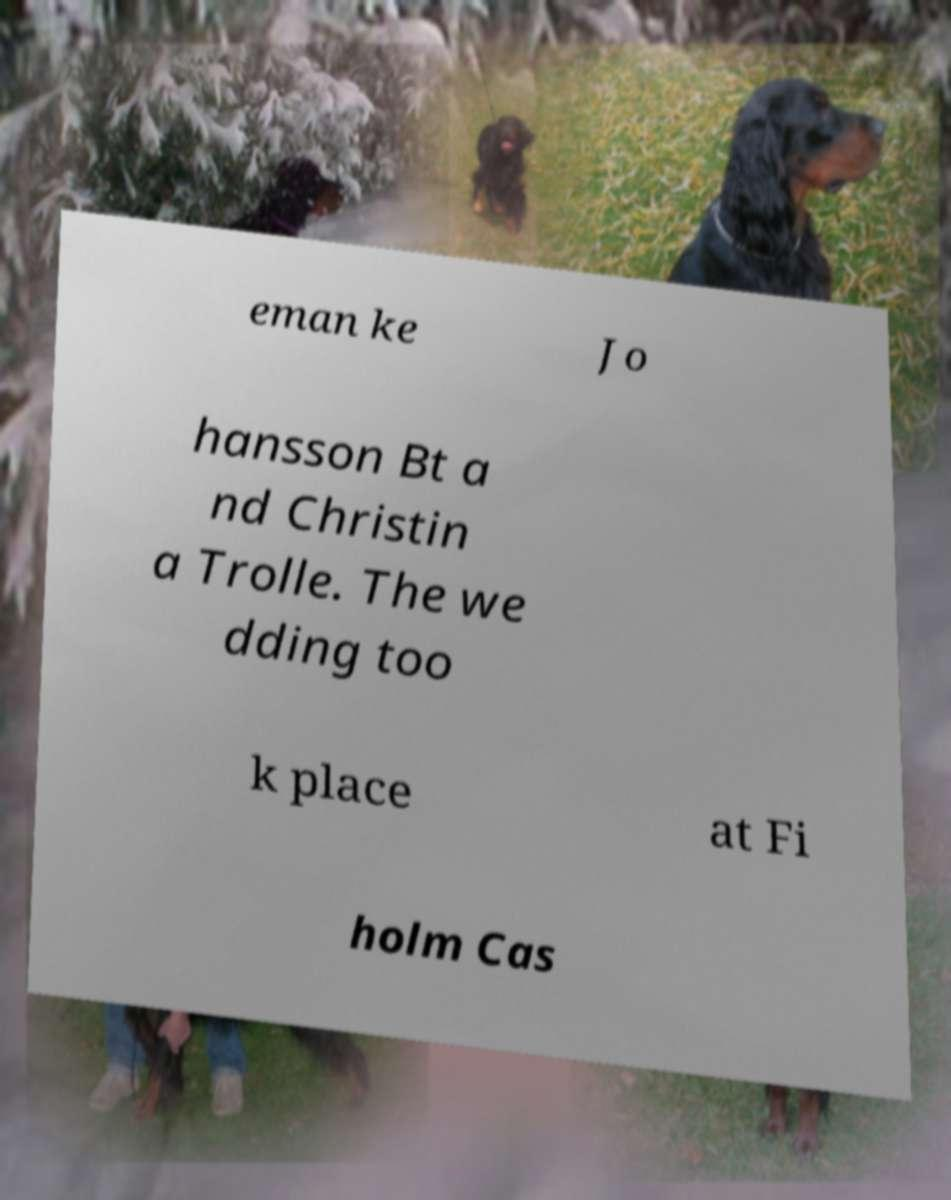Could you assist in decoding the text presented in this image and type it out clearly? eman ke Jo hansson Bt a nd Christin a Trolle. The we dding too k place at Fi holm Cas 